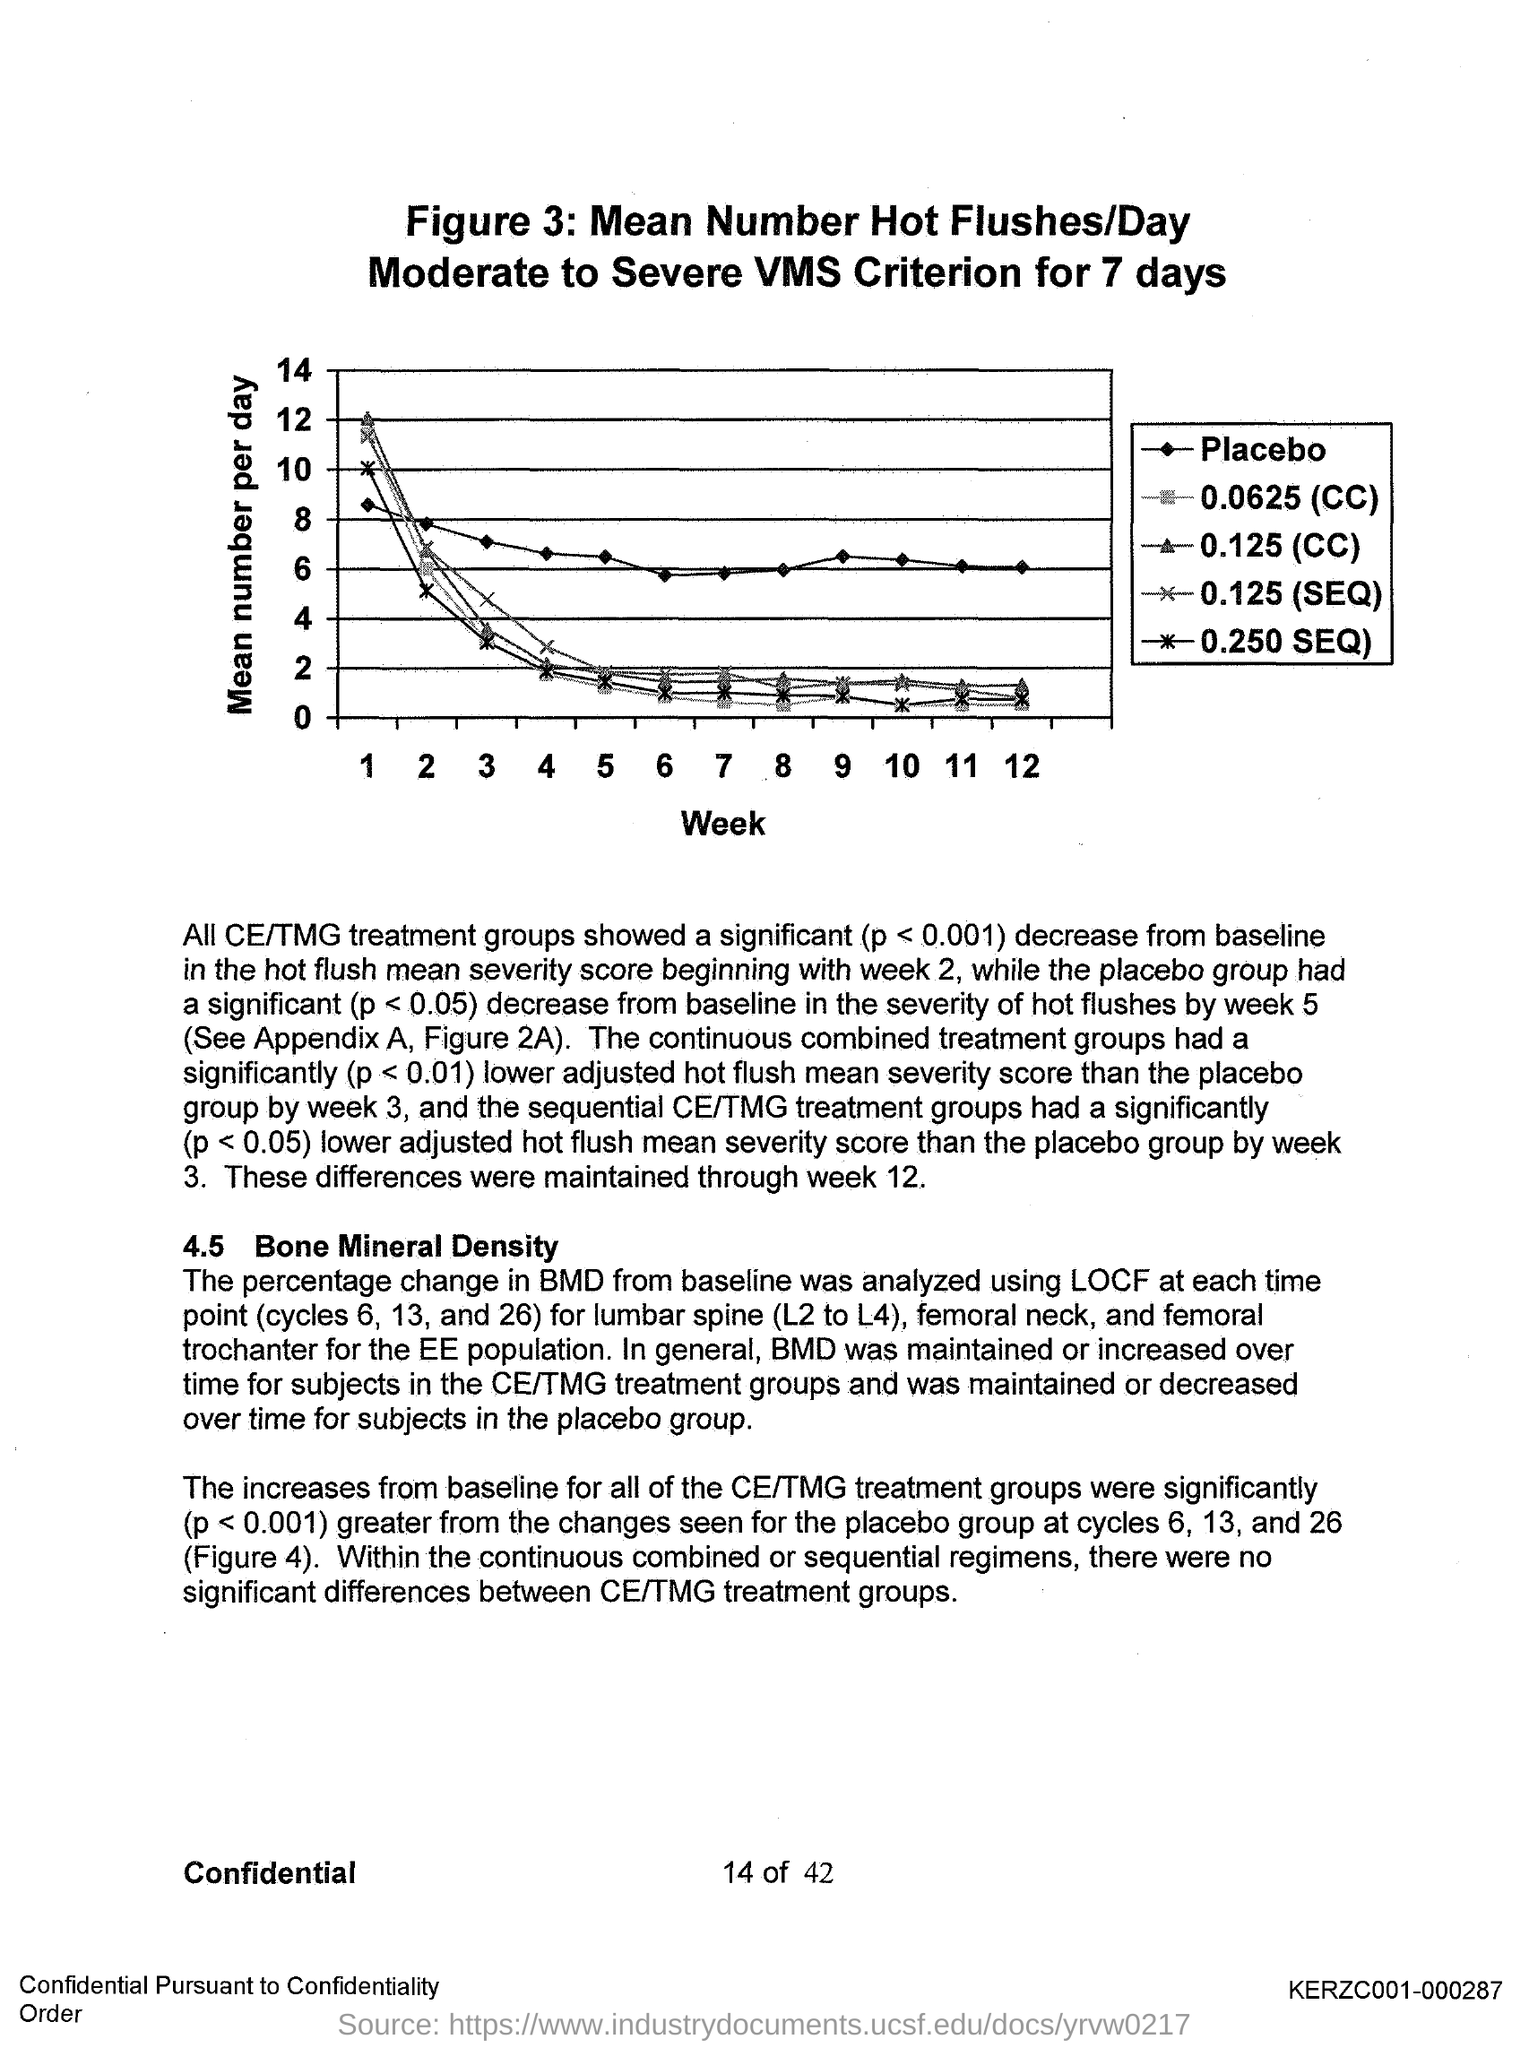What is plotted in the x-axis ?
Ensure brevity in your answer.  Week. What is plotted in the y-axis?
Keep it short and to the point. Mean number per day. 